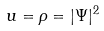<formula> <loc_0><loc_0><loc_500><loc_500>u = \rho = | \Psi | ^ { 2 }</formula> 